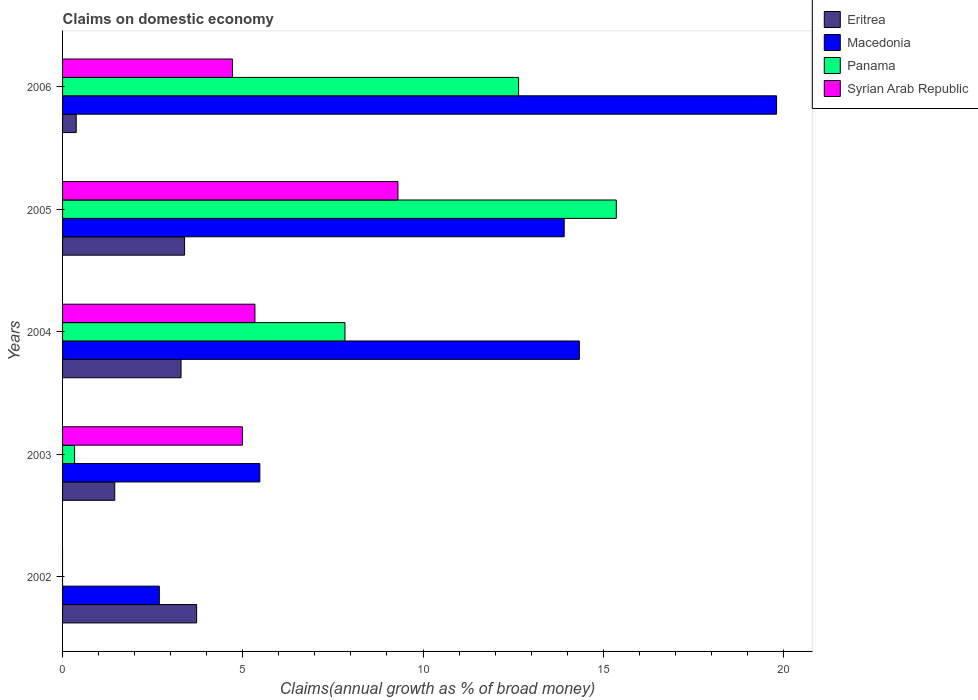How many different coloured bars are there?
Provide a succinct answer. 4. How many groups of bars are there?
Provide a succinct answer. 5. Are the number of bars on each tick of the Y-axis equal?
Your response must be concise. No. How many bars are there on the 5th tick from the bottom?
Provide a short and direct response. 4. What is the label of the 3rd group of bars from the top?
Offer a terse response. 2004. What is the percentage of broad money claimed on domestic economy in Macedonia in 2002?
Make the answer very short. 2.68. Across all years, what is the maximum percentage of broad money claimed on domestic economy in Eritrea?
Ensure brevity in your answer.  3.72. Across all years, what is the minimum percentage of broad money claimed on domestic economy in Macedonia?
Your answer should be compact. 2.68. What is the total percentage of broad money claimed on domestic economy in Syrian Arab Republic in the graph?
Your response must be concise. 24.34. What is the difference between the percentage of broad money claimed on domestic economy in Macedonia in 2003 and that in 2004?
Make the answer very short. -8.86. What is the difference between the percentage of broad money claimed on domestic economy in Eritrea in 2004 and the percentage of broad money claimed on domestic economy in Macedonia in 2006?
Keep it short and to the point. -16.52. What is the average percentage of broad money claimed on domestic economy in Eritrea per year?
Keep it short and to the point. 2.44. In the year 2002, what is the difference between the percentage of broad money claimed on domestic economy in Macedonia and percentage of broad money claimed on domestic economy in Eritrea?
Make the answer very short. -1.03. What is the ratio of the percentage of broad money claimed on domestic economy in Eritrea in 2002 to that in 2005?
Your response must be concise. 1.1. What is the difference between the highest and the second highest percentage of broad money claimed on domestic economy in Panama?
Your answer should be compact. 2.71. What is the difference between the highest and the lowest percentage of broad money claimed on domestic economy in Panama?
Make the answer very short. 15.36. In how many years, is the percentage of broad money claimed on domestic economy in Panama greater than the average percentage of broad money claimed on domestic economy in Panama taken over all years?
Make the answer very short. 3. Are all the bars in the graph horizontal?
Ensure brevity in your answer.  Yes. How many years are there in the graph?
Offer a terse response. 5. What is the difference between two consecutive major ticks on the X-axis?
Provide a succinct answer. 5. Are the values on the major ticks of X-axis written in scientific E-notation?
Keep it short and to the point. No. Does the graph contain any zero values?
Offer a terse response. Yes. Where does the legend appear in the graph?
Your answer should be compact. Top right. How many legend labels are there?
Ensure brevity in your answer.  4. What is the title of the graph?
Offer a very short reply. Claims on domestic economy. What is the label or title of the X-axis?
Provide a short and direct response. Claims(annual growth as % of broad money). What is the label or title of the Y-axis?
Your answer should be compact. Years. What is the Claims(annual growth as % of broad money) of Eritrea in 2002?
Keep it short and to the point. 3.72. What is the Claims(annual growth as % of broad money) in Macedonia in 2002?
Provide a succinct answer. 2.68. What is the Claims(annual growth as % of broad money) of Panama in 2002?
Make the answer very short. 0. What is the Claims(annual growth as % of broad money) of Eritrea in 2003?
Offer a terse response. 1.45. What is the Claims(annual growth as % of broad money) in Macedonia in 2003?
Provide a succinct answer. 5.47. What is the Claims(annual growth as % of broad money) of Panama in 2003?
Offer a terse response. 0.33. What is the Claims(annual growth as % of broad money) of Syrian Arab Republic in 2003?
Offer a very short reply. 4.99. What is the Claims(annual growth as % of broad money) in Eritrea in 2004?
Provide a short and direct response. 3.29. What is the Claims(annual growth as % of broad money) of Macedonia in 2004?
Your response must be concise. 14.34. What is the Claims(annual growth as % of broad money) in Panama in 2004?
Your response must be concise. 7.83. What is the Claims(annual growth as % of broad money) in Syrian Arab Republic in 2004?
Your answer should be compact. 5.34. What is the Claims(annual growth as % of broad money) in Eritrea in 2005?
Your answer should be very brief. 3.39. What is the Claims(annual growth as % of broad money) in Macedonia in 2005?
Provide a short and direct response. 13.92. What is the Claims(annual growth as % of broad money) of Panama in 2005?
Keep it short and to the point. 15.36. What is the Claims(annual growth as % of broad money) of Syrian Arab Republic in 2005?
Offer a terse response. 9.3. What is the Claims(annual growth as % of broad money) in Eritrea in 2006?
Your answer should be very brief. 0.38. What is the Claims(annual growth as % of broad money) of Macedonia in 2006?
Make the answer very short. 19.81. What is the Claims(annual growth as % of broad money) of Panama in 2006?
Provide a succinct answer. 12.65. What is the Claims(annual growth as % of broad money) in Syrian Arab Republic in 2006?
Your response must be concise. 4.71. Across all years, what is the maximum Claims(annual growth as % of broad money) in Eritrea?
Make the answer very short. 3.72. Across all years, what is the maximum Claims(annual growth as % of broad money) in Macedonia?
Your response must be concise. 19.81. Across all years, what is the maximum Claims(annual growth as % of broad money) of Panama?
Ensure brevity in your answer.  15.36. Across all years, what is the maximum Claims(annual growth as % of broad money) of Syrian Arab Republic?
Provide a succinct answer. 9.3. Across all years, what is the minimum Claims(annual growth as % of broad money) of Eritrea?
Ensure brevity in your answer.  0.38. Across all years, what is the minimum Claims(annual growth as % of broad money) of Macedonia?
Make the answer very short. 2.68. Across all years, what is the minimum Claims(annual growth as % of broad money) of Syrian Arab Republic?
Give a very brief answer. 0. What is the total Claims(annual growth as % of broad money) in Eritrea in the graph?
Your response must be concise. 12.22. What is the total Claims(annual growth as % of broad money) in Macedonia in the graph?
Provide a succinct answer. 56.22. What is the total Claims(annual growth as % of broad money) of Panama in the graph?
Provide a short and direct response. 36.18. What is the total Claims(annual growth as % of broad money) in Syrian Arab Republic in the graph?
Your response must be concise. 24.34. What is the difference between the Claims(annual growth as % of broad money) of Eritrea in 2002 and that in 2003?
Give a very brief answer. 2.27. What is the difference between the Claims(annual growth as % of broad money) in Macedonia in 2002 and that in 2003?
Ensure brevity in your answer.  -2.79. What is the difference between the Claims(annual growth as % of broad money) in Eritrea in 2002 and that in 2004?
Offer a very short reply. 0.43. What is the difference between the Claims(annual growth as % of broad money) in Macedonia in 2002 and that in 2004?
Offer a very short reply. -11.65. What is the difference between the Claims(annual growth as % of broad money) in Eritrea in 2002 and that in 2005?
Ensure brevity in your answer.  0.33. What is the difference between the Claims(annual growth as % of broad money) of Macedonia in 2002 and that in 2005?
Provide a short and direct response. -11.23. What is the difference between the Claims(annual growth as % of broad money) of Eritrea in 2002 and that in 2006?
Give a very brief answer. 3.34. What is the difference between the Claims(annual growth as % of broad money) of Macedonia in 2002 and that in 2006?
Your answer should be very brief. -17.12. What is the difference between the Claims(annual growth as % of broad money) of Eritrea in 2003 and that in 2004?
Offer a terse response. -1.84. What is the difference between the Claims(annual growth as % of broad money) in Macedonia in 2003 and that in 2004?
Give a very brief answer. -8.86. What is the difference between the Claims(annual growth as % of broad money) in Panama in 2003 and that in 2004?
Ensure brevity in your answer.  -7.5. What is the difference between the Claims(annual growth as % of broad money) in Syrian Arab Republic in 2003 and that in 2004?
Provide a succinct answer. -0.35. What is the difference between the Claims(annual growth as % of broad money) of Eritrea in 2003 and that in 2005?
Keep it short and to the point. -1.94. What is the difference between the Claims(annual growth as % of broad money) of Macedonia in 2003 and that in 2005?
Your answer should be very brief. -8.44. What is the difference between the Claims(annual growth as % of broad money) of Panama in 2003 and that in 2005?
Your answer should be compact. -15.03. What is the difference between the Claims(annual growth as % of broad money) of Syrian Arab Republic in 2003 and that in 2005?
Make the answer very short. -4.32. What is the difference between the Claims(annual growth as % of broad money) in Eritrea in 2003 and that in 2006?
Provide a succinct answer. 1.07. What is the difference between the Claims(annual growth as % of broad money) in Macedonia in 2003 and that in 2006?
Offer a very short reply. -14.34. What is the difference between the Claims(annual growth as % of broad money) in Panama in 2003 and that in 2006?
Ensure brevity in your answer.  -12.32. What is the difference between the Claims(annual growth as % of broad money) of Syrian Arab Republic in 2003 and that in 2006?
Keep it short and to the point. 0.28. What is the difference between the Claims(annual growth as % of broad money) of Eritrea in 2004 and that in 2005?
Provide a short and direct response. -0.1. What is the difference between the Claims(annual growth as % of broad money) of Macedonia in 2004 and that in 2005?
Your answer should be very brief. 0.42. What is the difference between the Claims(annual growth as % of broad money) in Panama in 2004 and that in 2005?
Make the answer very short. -7.53. What is the difference between the Claims(annual growth as % of broad money) in Syrian Arab Republic in 2004 and that in 2005?
Provide a succinct answer. -3.97. What is the difference between the Claims(annual growth as % of broad money) of Eritrea in 2004 and that in 2006?
Ensure brevity in your answer.  2.91. What is the difference between the Claims(annual growth as % of broad money) in Macedonia in 2004 and that in 2006?
Keep it short and to the point. -5.47. What is the difference between the Claims(annual growth as % of broad money) of Panama in 2004 and that in 2006?
Your response must be concise. -4.82. What is the difference between the Claims(annual growth as % of broad money) of Syrian Arab Republic in 2004 and that in 2006?
Offer a very short reply. 0.62. What is the difference between the Claims(annual growth as % of broad money) of Eritrea in 2005 and that in 2006?
Your response must be concise. 3.01. What is the difference between the Claims(annual growth as % of broad money) in Macedonia in 2005 and that in 2006?
Provide a short and direct response. -5.89. What is the difference between the Claims(annual growth as % of broad money) of Panama in 2005 and that in 2006?
Keep it short and to the point. 2.71. What is the difference between the Claims(annual growth as % of broad money) in Syrian Arab Republic in 2005 and that in 2006?
Your response must be concise. 4.59. What is the difference between the Claims(annual growth as % of broad money) in Eritrea in 2002 and the Claims(annual growth as % of broad money) in Macedonia in 2003?
Offer a very short reply. -1.75. What is the difference between the Claims(annual growth as % of broad money) in Eritrea in 2002 and the Claims(annual growth as % of broad money) in Panama in 2003?
Offer a terse response. 3.39. What is the difference between the Claims(annual growth as % of broad money) in Eritrea in 2002 and the Claims(annual growth as % of broad money) in Syrian Arab Republic in 2003?
Offer a terse response. -1.27. What is the difference between the Claims(annual growth as % of broad money) of Macedonia in 2002 and the Claims(annual growth as % of broad money) of Panama in 2003?
Keep it short and to the point. 2.35. What is the difference between the Claims(annual growth as % of broad money) of Macedonia in 2002 and the Claims(annual growth as % of broad money) of Syrian Arab Republic in 2003?
Ensure brevity in your answer.  -2.3. What is the difference between the Claims(annual growth as % of broad money) in Eritrea in 2002 and the Claims(annual growth as % of broad money) in Macedonia in 2004?
Provide a short and direct response. -10.62. What is the difference between the Claims(annual growth as % of broad money) of Eritrea in 2002 and the Claims(annual growth as % of broad money) of Panama in 2004?
Keep it short and to the point. -4.12. What is the difference between the Claims(annual growth as % of broad money) in Eritrea in 2002 and the Claims(annual growth as % of broad money) in Syrian Arab Republic in 2004?
Keep it short and to the point. -1.62. What is the difference between the Claims(annual growth as % of broad money) in Macedonia in 2002 and the Claims(annual growth as % of broad money) in Panama in 2004?
Give a very brief answer. -5.15. What is the difference between the Claims(annual growth as % of broad money) of Macedonia in 2002 and the Claims(annual growth as % of broad money) of Syrian Arab Republic in 2004?
Provide a short and direct response. -2.65. What is the difference between the Claims(annual growth as % of broad money) in Eritrea in 2002 and the Claims(annual growth as % of broad money) in Macedonia in 2005?
Your response must be concise. -10.2. What is the difference between the Claims(annual growth as % of broad money) in Eritrea in 2002 and the Claims(annual growth as % of broad money) in Panama in 2005?
Keep it short and to the point. -11.64. What is the difference between the Claims(annual growth as % of broad money) in Eritrea in 2002 and the Claims(annual growth as % of broad money) in Syrian Arab Republic in 2005?
Your response must be concise. -5.58. What is the difference between the Claims(annual growth as % of broad money) in Macedonia in 2002 and the Claims(annual growth as % of broad money) in Panama in 2005?
Your answer should be very brief. -12.68. What is the difference between the Claims(annual growth as % of broad money) in Macedonia in 2002 and the Claims(annual growth as % of broad money) in Syrian Arab Republic in 2005?
Your answer should be compact. -6.62. What is the difference between the Claims(annual growth as % of broad money) in Eritrea in 2002 and the Claims(annual growth as % of broad money) in Macedonia in 2006?
Your response must be concise. -16.09. What is the difference between the Claims(annual growth as % of broad money) of Eritrea in 2002 and the Claims(annual growth as % of broad money) of Panama in 2006?
Keep it short and to the point. -8.93. What is the difference between the Claims(annual growth as % of broad money) of Eritrea in 2002 and the Claims(annual growth as % of broad money) of Syrian Arab Republic in 2006?
Make the answer very short. -0.99. What is the difference between the Claims(annual growth as % of broad money) of Macedonia in 2002 and the Claims(annual growth as % of broad money) of Panama in 2006?
Keep it short and to the point. -9.97. What is the difference between the Claims(annual growth as % of broad money) in Macedonia in 2002 and the Claims(annual growth as % of broad money) in Syrian Arab Republic in 2006?
Ensure brevity in your answer.  -2.03. What is the difference between the Claims(annual growth as % of broad money) of Eritrea in 2003 and the Claims(annual growth as % of broad money) of Macedonia in 2004?
Offer a very short reply. -12.89. What is the difference between the Claims(annual growth as % of broad money) of Eritrea in 2003 and the Claims(annual growth as % of broad money) of Panama in 2004?
Make the answer very short. -6.39. What is the difference between the Claims(annual growth as % of broad money) of Eritrea in 2003 and the Claims(annual growth as % of broad money) of Syrian Arab Republic in 2004?
Ensure brevity in your answer.  -3.89. What is the difference between the Claims(annual growth as % of broad money) in Macedonia in 2003 and the Claims(annual growth as % of broad money) in Panama in 2004?
Ensure brevity in your answer.  -2.36. What is the difference between the Claims(annual growth as % of broad money) in Macedonia in 2003 and the Claims(annual growth as % of broad money) in Syrian Arab Republic in 2004?
Keep it short and to the point. 0.14. What is the difference between the Claims(annual growth as % of broad money) in Panama in 2003 and the Claims(annual growth as % of broad money) in Syrian Arab Republic in 2004?
Your answer should be very brief. -5. What is the difference between the Claims(annual growth as % of broad money) of Eritrea in 2003 and the Claims(annual growth as % of broad money) of Macedonia in 2005?
Ensure brevity in your answer.  -12.47. What is the difference between the Claims(annual growth as % of broad money) in Eritrea in 2003 and the Claims(annual growth as % of broad money) in Panama in 2005?
Give a very brief answer. -13.92. What is the difference between the Claims(annual growth as % of broad money) of Eritrea in 2003 and the Claims(annual growth as % of broad money) of Syrian Arab Republic in 2005?
Your response must be concise. -7.86. What is the difference between the Claims(annual growth as % of broad money) in Macedonia in 2003 and the Claims(annual growth as % of broad money) in Panama in 2005?
Your answer should be very brief. -9.89. What is the difference between the Claims(annual growth as % of broad money) in Macedonia in 2003 and the Claims(annual growth as % of broad money) in Syrian Arab Republic in 2005?
Make the answer very short. -3.83. What is the difference between the Claims(annual growth as % of broad money) in Panama in 2003 and the Claims(annual growth as % of broad money) in Syrian Arab Republic in 2005?
Provide a succinct answer. -8.97. What is the difference between the Claims(annual growth as % of broad money) in Eritrea in 2003 and the Claims(annual growth as % of broad money) in Macedonia in 2006?
Give a very brief answer. -18.36. What is the difference between the Claims(annual growth as % of broad money) in Eritrea in 2003 and the Claims(annual growth as % of broad money) in Panama in 2006?
Your answer should be compact. -11.2. What is the difference between the Claims(annual growth as % of broad money) in Eritrea in 2003 and the Claims(annual growth as % of broad money) in Syrian Arab Republic in 2006?
Your answer should be compact. -3.27. What is the difference between the Claims(annual growth as % of broad money) of Macedonia in 2003 and the Claims(annual growth as % of broad money) of Panama in 2006?
Keep it short and to the point. -7.18. What is the difference between the Claims(annual growth as % of broad money) of Macedonia in 2003 and the Claims(annual growth as % of broad money) of Syrian Arab Republic in 2006?
Give a very brief answer. 0.76. What is the difference between the Claims(annual growth as % of broad money) in Panama in 2003 and the Claims(annual growth as % of broad money) in Syrian Arab Republic in 2006?
Your answer should be compact. -4.38. What is the difference between the Claims(annual growth as % of broad money) in Eritrea in 2004 and the Claims(annual growth as % of broad money) in Macedonia in 2005?
Provide a succinct answer. -10.63. What is the difference between the Claims(annual growth as % of broad money) of Eritrea in 2004 and the Claims(annual growth as % of broad money) of Panama in 2005?
Your answer should be very brief. -12.08. What is the difference between the Claims(annual growth as % of broad money) of Eritrea in 2004 and the Claims(annual growth as % of broad money) of Syrian Arab Republic in 2005?
Offer a terse response. -6.02. What is the difference between the Claims(annual growth as % of broad money) of Macedonia in 2004 and the Claims(annual growth as % of broad money) of Panama in 2005?
Ensure brevity in your answer.  -1.02. What is the difference between the Claims(annual growth as % of broad money) of Macedonia in 2004 and the Claims(annual growth as % of broad money) of Syrian Arab Republic in 2005?
Offer a very short reply. 5.03. What is the difference between the Claims(annual growth as % of broad money) in Panama in 2004 and the Claims(annual growth as % of broad money) in Syrian Arab Republic in 2005?
Offer a very short reply. -1.47. What is the difference between the Claims(annual growth as % of broad money) of Eritrea in 2004 and the Claims(annual growth as % of broad money) of Macedonia in 2006?
Offer a very short reply. -16.52. What is the difference between the Claims(annual growth as % of broad money) of Eritrea in 2004 and the Claims(annual growth as % of broad money) of Panama in 2006?
Provide a short and direct response. -9.37. What is the difference between the Claims(annual growth as % of broad money) of Eritrea in 2004 and the Claims(annual growth as % of broad money) of Syrian Arab Republic in 2006?
Your response must be concise. -1.43. What is the difference between the Claims(annual growth as % of broad money) of Macedonia in 2004 and the Claims(annual growth as % of broad money) of Panama in 2006?
Offer a terse response. 1.69. What is the difference between the Claims(annual growth as % of broad money) of Macedonia in 2004 and the Claims(annual growth as % of broad money) of Syrian Arab Republic in 2006?
Make the answer very short. 9.62. What is the difference between the Claims(annual growth as % of broad money) in Panama in 2004 and the Claims(annual growth as % of broad money) in Syrian Arab Republic in 2006?
Give a very brief answer. 3.12. What is the difference between the Claims(annual growth as % of broad money) in Eritrea in 2005 and the Claims(annual growth as % of broad money) in Macedonia in 2006?
Keep it short and to the point. -16.42. What is the difference between the Claims(annual growth as % of broad money) in Eritrea in 2005 and the Claims(annual growth as % of broad money) in Panama in 2006?
Provide a short and direct response. -9.27. What is the difference between the Claims(annual growth as % of broad money) of Eritrea in 2005 and the Claims(annual growth as % of broad money) of Syrian Arab Republic in 2006?
Give a very brief answer. -1.33. What is the difference between the Claims(annual growth as % of broad money) in Macedonia in 2005 and the Claims(annual growth as % of broad money) in Panama in 2006?
Provide a succinct answer. 1.27. What is the difference between the Claims(annual growth as % of broad money) in Macedonia in 2005 and the Claims(annual growth as % of broad money) in Syrian Arab Republic in 2006?
Offer a terse response. 9.2. What is the difference between the Claims(annual growth as % of broad money) in Panama in 2005 and the Claims(annual growth as % of broad money) in Syrian Arab Republic in 2006?
Provide a succinct answer. 10.65. What is the average Claims(annual growth as % of broad money) of Eritrea per year?
Your answer should be compact. 2.44. What is the average Claims(annual growth as % of broad money) of Macedonia per year?
Provide a short and direct response. 11.24. What is the average Claims(annual growth as % of broad money) of Panama per year?
Offer a terse response. 7.24. What is the average Claims(annual growth as % of broad money) in Syrian Arab Republic per year?
Offer a very short reply. 4.87. In the year 2002, what is the difference between the Claims(annual growth as % of broad money) of Eritrea and Claims(annual growth as % of broad money) of Macedonia?
Offer a terse response. 1.03. In the year 2003, what is the difference between the Claims(annual growth as % of broad money) in Eritrea and Claims(annual growth as % of broad money) in Macedonia?
Your response must be concise. -4.03. In the year 2003, what is the difference between the Claims(annual growth as % of broad money) of Eritrea and Claims(annual growth as % of broad money) of Panama?
Provide a short and direct response. 1.11. In the year 2003, what is the difference between the Claims(annual growth as % of broad money) in Eritrea and Claims(annual growth as % of broad money) in Syrian Arab Republic?
Offer a very short reply. -3.54. In the year 2003, what is the difference between the Claims(annual growth as % of broad money) of Macedonia and Claims(annual growth as % of broad money) of Panama?
Offer a very short reply. 5.14. In the year 2003, what is the difference between the Claims(annual growth as % of broad money) of Macedonia and Claims(annual growth as % of broad money) of Syrian Arab Republic?
Make the answer very short. 0.48. In the year 2003, what is the difference between the Claims(annual growth as % of broad money) of Panama and Claims(annual growth as % of broad money) of Syrian Arab Republic?
Offer a very short reply. -4.66. In the year 2004, what is the difference between the Claims(annual growth as % of broad money) in Eritrea and Claims(annual growth as % of broad money) in Macedonia?
Offer a very short reply. -11.05. In the year 2004, what is the difference between the Claims(annual growth as % of broad money) in Eritrea and Claims(annual growth as % of broad money) in Panama?
Ensure brevity in your answer.  -4.55. In the year 2004, what is the difference between the Claims(annual growth as % of broad money) of Eritrea and Claims(annual growth as % of broad money) of Syrian Arab Republic?
Offer a very short reply. -2.05. In the year 2004, what is the difference between the Claims(annual growth as % of broad money) in Macedonia and Claims(annual growth as % of broad money) in Panama?
Your response must be concise. 6.5. In the year 2004, what is the difference between the Claims(annual growth as % of broad money) in Macedonia and Claims(annual growth as % of broad money) in Syrian Arab Republic?
Provide a short and direct response. 9. In the year 2004, what is the difference between the Claims(annual growth as % of broad money) in Panama and Claims(annual growth as % of broad money) in Syrian Arab Republic?
Your answer should be very brief. 2.5. In the year 2005, what is the difference between the Claims(annual growth as % of broad money) of Eritrea and Claims(annual growth as % of broad money) of Macedonia?
Keep it short and to the point. -10.53. In the year 2005, what is the difference between the Claims(annual growth as % of broad money) in Eritrea and Claims(annual growth as % of broad money) in Panama?
Make the answer very short. -11.98. In the year 2005, what is the difference between the Claims(annual growth as % of broad money) of Eritrea and Claims(annual growth as % of broad money) of Syrian Arab Republic?
Make the answer very short. -5.92. In the year 2005, what is the difference between the Claims(annual growth as % of broad money) in Macedonia and Claims(annual growth as % of broad money) in Panama?
Provide a short and direct response. -1.45. In the year 2005, what is the difference between the Claims(annual growth as % of broad money) in Macedonia and Claims(annual growth as % of broad money) in Syrian Arab Republic?
Your answer should be compact. 4.61. In the year 2005, what is the difference between the Claims(annual growth as % of broad money) of Panama and Claims(annual growth as % of broad money) of Syrian Arab Republic?
Your answer should be compact. 6.06. In the year 2006, what is the difference between the Claims(annual growth as % of broad money) in Eritrea and Claims(annual growth as % of broad money) in Macedonia?
Keep it short and to the point. -19.43. In the year 2006, what is the difference between the Claims(annual growth as % of broad money) in Eritrea and Claims(annual growth as % of broad money) in Panama?
Ensure brevity in your answer.  -12.27. In the year 2006, what is the difference between the Claims(annual growth as % of broad money) of Eritrea and Claims(annual growth as % of broad money) of Syrian Arab Republic?
Your response must be concise. -4.33. In the year 2006, what is the difference between the Claims(annual growth as % of broad money) in Macedonia and Claims(annual growth as % of broad money) in Panama?
Keep it short and to the point. 7.16. In the year 2006, what is the difference between the Claims(annual growth as % of broad money) of Macedonia and Claims(annual growth as % of broad money) of Syrian Arab Republic?
Ensure brevity in your answer.  15.1. In the year 2006, what is the difference between the Claims(annual growth as % of broad money) in Panama and Claims(annual growth as % of broad money) in Syrian Arab Republic?
Offer a very short reply. 7.94. What is the ratio of the Claims(annual growth as % of broad money) of Eritrea in 2002 to that in 2003?
Make the answer very short. 2.57. What is the ratio of the Claims(annual growth as % of broad money) in Macedonia in 2002 to that in 2003?
Your response must be concise. 0.49. What is the ratio of the Claims(annual growth as % of broad money) in Eritrea in 2002 to that in 2004?
Your response must be concise. 1.13. What is the ratio of the Claims(annual growth as % of broad money) in Macedonia in 2002 to that in 2004?
Ensure brevity in your answer.  0.19. What is the ratio of the Claims(annual growth as % of broad money) of Eritrea in 2002 to that in 2005?
Offer a very short reply. 1.1. What is the ratio of the Claims(annual growth as % of broad money) in Macedonia in 2002 to that in 2005?
Your answer should be compact. 0.19. What is the ratio of the Claims(annual growth as % of broad money) of Eritrea in 2002 to that in 2006?
Keep it short and to the point. 9.81. What is the ratio of the Claims(annual growth as % of broad money) of Macedonia in 2002 to that in 2006?
Your response must be concise. 0.14. What is the ratio of the Claims(annual growth as % of broad money) in Eritrea in 2003 to that in 2004?
Keep it short and to the point. 0.44. What is the ratio of the Claims(annual growth as % of broad money) in Macedonia in 2003 to that in 2004?
Offer a very short reply. 0.38. What is the ratio of the Claims(annual growth as % of broad money) of Panama in 2003 to that in 2004?
Keep it short and to the point. 0.04. What is the ratio of the Claims(annual growth as % of broad money) of Syrian Arab Republic in 2003 to that in 2004?
Offer a terse response. 0.93. What is the ratio of the Claims(annual growth as % of broad money) of Eritrea in 2003 to that in 2005?
Keep it short and to the point. 0.43. What is the ratio of the Claims(annual growth as % of broad money) of Macedonia in 2003 to that in 2005?
Give a very brief answer. 0.39. What is the ratio of the Claims(annual growth as % of broad money) in Panama in 2003 to that in 2005?
Your answer should be compact. 0.02. What is the ratio of the Claims(annual growth as % of broad money) of Syrian Arab Republic in 2003 to that in 2005?
Offer a terse response. 0.54. What is the ratio of the Claims(annual growth as % of broad money) in Eritrea in 2003 to that in 2006?
Make the answer very short. 3.82. What is the ratio of the Claims(annual growth as % of broad money) of Macedonia in 2003 to that in 2006?
Provide a short and direct response. 0.28. What is the ratio of the Claims(annual growth as % of broad money) in Panama in 2003 to that in 2006?
Offer a terse response. 0.03. What is the ratio of the Claims(annual growth as % of broad money) in Syrian Arab Republic in 2003 to that in 2006?
Provide a short and direct response. 1.06. What is the ratio of the Claims(annual growth as % of broad money) of Macedonia in 2004 to that in 2005?
Your answer should be very brief. 1.03. What is the ratio of the Claims(annual growth as % of broad money) of Panama in 2004 to that in 2005?
Offer a very short reply. 0.51. What is the ratio of the Claims(annual growth as % of broad money) of Syrian Arab Republic in 2004 to that in 2005?
Your response must be concise. 0.57. What is the ratio of the Claims(annual growth as % of broad money) of Eritrea in 2004 to that in 2006?
Provide a short and direct response. 8.67. What is the ratio of the Claims(annual growth as % of broad money) in Macedonia in 2004 to that in 2006?
Your answer should be compact. 0.72. What is the ratio of the Claims(annual growth as % of broad money) of Panama in 2004 to that in 2006?
Your response must be concise. 0.62. What is the ratio of the Claims(annual growth as % of broad money) in Syrian Arab Republic in 2004 to that in 2006?
Your answer should be compact. 1.13. What is the ratio of the Claims(annual growth as % of broad money) of Eritrea in 2005 to that in 2006?
Provide a succinct answer. 8.93. What is the ratio of the Claims(annual growth as % of broad money) of Macedonia in 2005 to that in 2006?
Your answer should be very brief. 0.7. What is the ratio of the Claims(annual growth as % of broad money) of Panama in 2005 to that in 2006?
Make the answer very short. 1.21. What is the ratio of the Claims(annual growth as % of broad money) of Syrian Arab Republic in 2005 to that in 2006?
Give a very brief answer. 1.97. What is the difference between the highest and the second highest Claims(annual growth as % of broad money) of Eritrea?
Keep it short and to the point. 0.33. What is the difference between the highest and the second highest Claims(annual growth as % of broad money) of Macedonia?
Give a very brief answer. 5.47. What is the difference between the highest and the second highest Claims(annual growth as % of broad money) of Panama?
Give a very brief answer. 2.71. What is the difference between the highest and the second highest Claims(annual growth as % of broad money) in Syrian Arab Republic?
Provide a succinct answer. 3.97. What is the difference between the highest and the lowest Claims(annual growth as % of broad money) in Eritrea?
Make the answer very short. 3.34. What is the difference between the highest and the lowest Claims(annual growth as % of broad money) in Macedonia?
Offer a very short reply. 17.12. What is the difference between the highest and the lowest Claims(annual growth as % of broad money) of Panama?
Make the answer very short. 15.36. What is the difference between the highest and the lowest Claims(annual growth as % of broad money) in Syrian Arab Republic?
Ensure brevity in your answer.  9.3. 